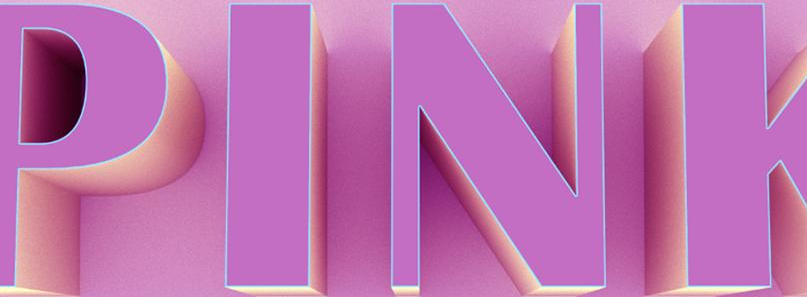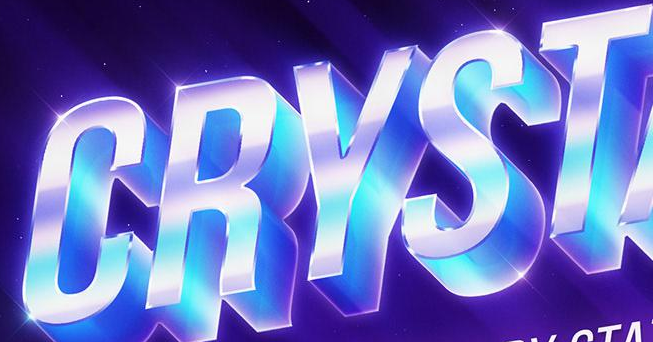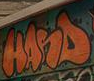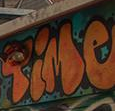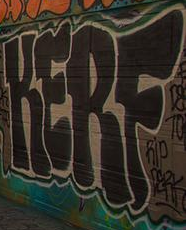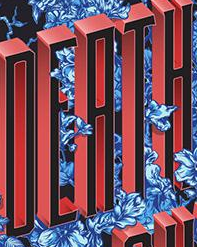What words are shown in these images in order, separated by a semicolon? PINK; CRYST; HANS; Time; KERF; DEATH 